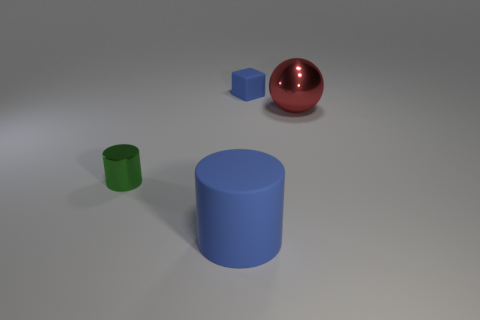There is a small thing in front of the small blue matte object; is its shape the same as the blue rubber thing that is right of the large blue cylinder?
Your response must be concise. No. There is a rubber cylinder that is the same size as the red metallic object; what color is it?
Keep it short and to the point. Blue. How many blue things are the same shape as the green thing?
Offer a terse response. 1. Does the small object in front of the big sphere have the same material as the big red sphere?
Make the answer very short. Yes. What is the shape of the small object that is the same color as the big rubber thing?
Your response must be concise. Cube. Is the blue matte block the same size as the green metallic object?
Your response must be concise. Yes. How many objects are either blue rubber objects that are in front of the big metallic object or blue matte objects behind the large blue rubber cylinder?
Your answer should be very brief. 2. There is a cylinder that is behind the cylinder that is in front of the tiny green metallic thing; what is its material?
Provide a short and direct response. Metal. How many other things are there of the same material as the small green cylinder?
Your response must be concise. 1. Does the large metal thing have the same shape as the tiny green object?
Make the answer very short. No. 